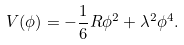Convert formula to latex. <formula><loc_0><loc_0><loc_500><loc_500>V ( \phi ) = - \frac { 1 } { 6 } R \phi ^ { 2 } + \lambda ^ { 2 } \phi ^ { 4 } .</formula> 